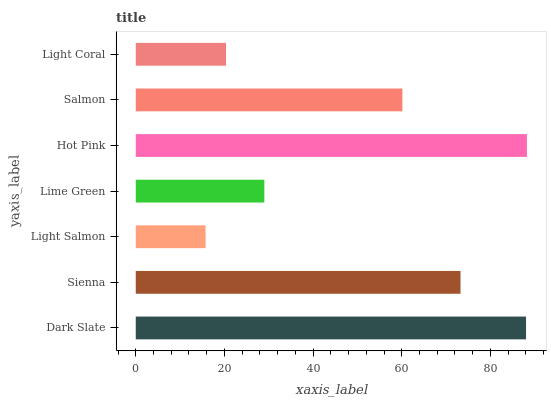Is Light Salmon the minimum?
Answer yes or no. Yes. Is Hot Pink the maximum?
Answer yes or no. Yes. Is Sienna the minimum?
Answer yes or no. No. Is Sienna the maximum?
Answer yes or no. No. Is Dark Slate greater than Sienna?
Answer yes or no. Yes. Is Sienna less than Dark Slate?
Answer yes or no. Yes. Is Sienna greater than Dark Slate?
Answer yes or no. No. Is Dark Slate less than Sienna?
Answer yes or no. No. Is Salmon the high median?
Answer yes or no. Yes. Is Salmon the low median?
Answer yes or no. Yes. Is Dark Slate the high median?
Answer yes or no. No. Is Hot Pink the low median?
Answer yes or no. No. 